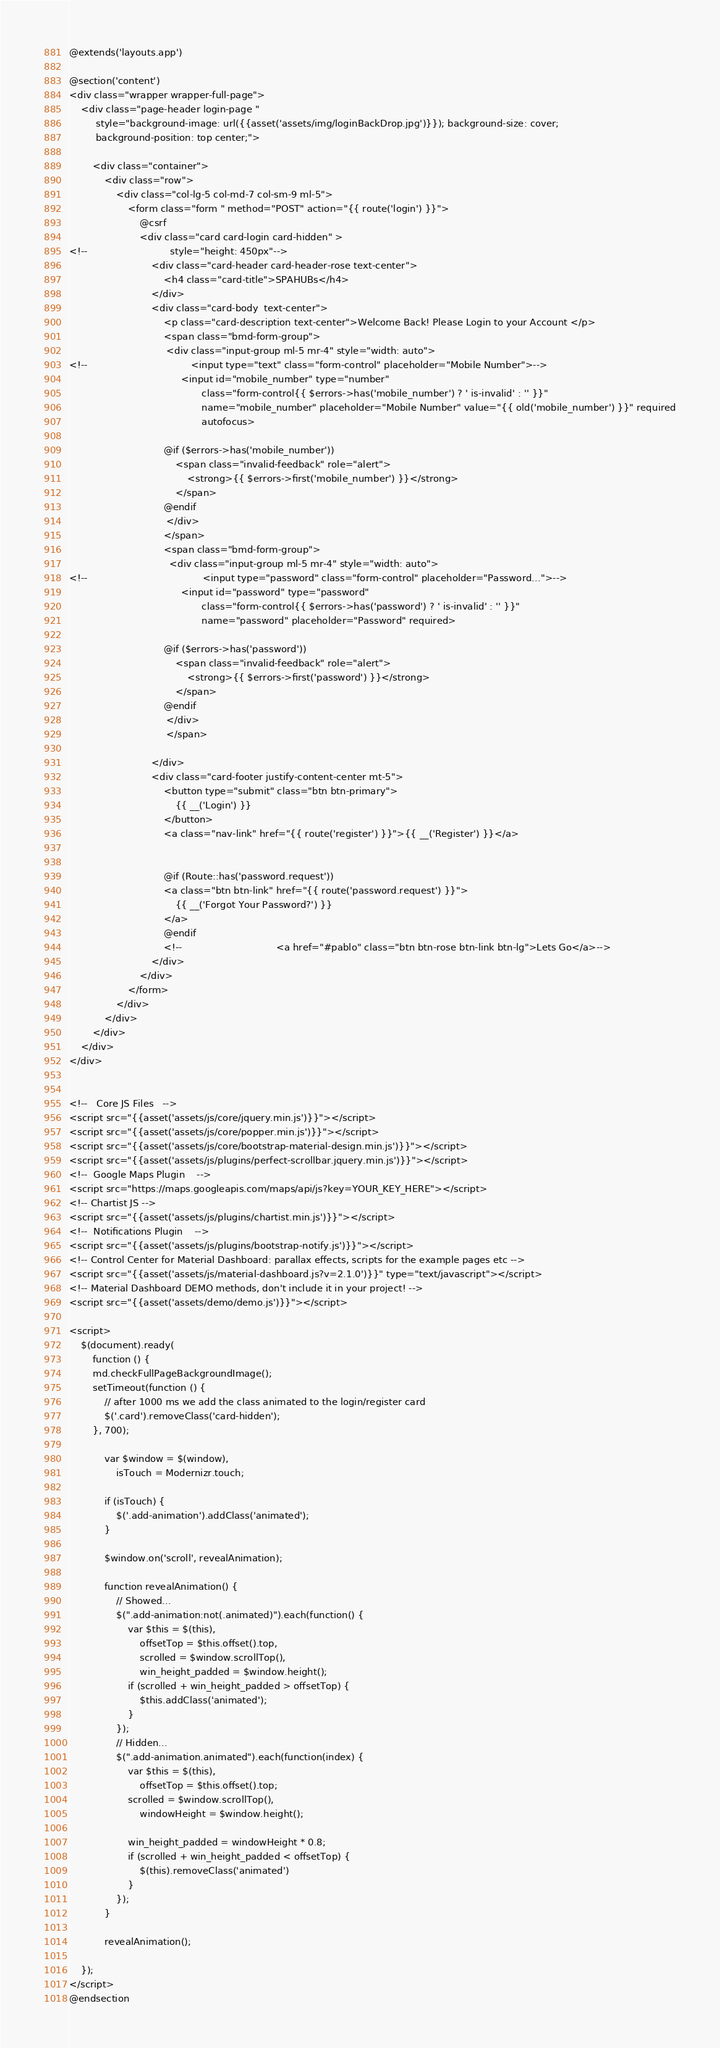<code> <loc_0><loc_0><loc_500><loc_500><_PHP_>@extends('layouts.app')

@section('content')
<div class="wrapper wrapper-full-page">
    <div class="page-header login-page "
         style="background-image: url({{asset('assets/img/loginBackDrop.jpg')}}); background-size: cover;
         background-position: top center;">

        <div class="container">
            <div class="row">
                <div class="col-lg-5 col-md-7 col-sm-9 ml-5">
                    <form class="form " method="POST" action="{{ route('login') }}">
                        @csrf
                        <div class="card card-login card-hidden" >
<!--                            style="height: 450px"-->
                            <div class="card-header card-header-rose text-center">
                                <h4 class="card-title">SPAHUBs</h4>
                            </div>
                            <div class="card-body  text-center">
                                <p class="card-description text-center">Welcome Back! Please Login to your Account </p>
                                <span class="bmd-form-group">
                                 <div class="input-group ml-5 mr-4" style="width: auto">
<!--                                   <input type="text" class="form-control" placeholder="Mobile Number">-->
                                      <input id="mobile_number" type="number"
                                             class="form-control{{ $errors->has('mobile_number') ? ' is-invalid' : '' }}"
                                             name="mobile_number" placeholder="Mobile Number" value="{{ old('mobile_number') }}" required
                                             autofocus>

                                @if ($errors->has('mobile_number'))
                                    <span class="invalid-feedback" role="alert">
                                        <strong>{{ $errors->first('mobile_number') }}</strong>
                                    </span>
                                @endif
                                 </div>
                                </span>
                                <span class="bmd-form-group">
                                  <div class="input-group ml-5 mr-4" style="width: auto">
<!--                                       <input type="password" class="form-control" placeholder="Password...">-->
                                      <input id="password" type="password"
                                             class="form-control{{ $errors->has('password') ? ' is-invalid' : '' }}"
                                             name="password" placeholder="Password" required>

                                @if ($errors->has('password'))
                                    <span class="invalid-feedback" role="alert">
                                        <strong>{{ $errors->first('password') }}</strong>
                                    </span>
                                @endif
                                 </div>
                                 </span>

                            </div>
                            <div class="card-footer justify-content-center mt-5">
                                <button type="submit" class="btn btn-primary">
                                    {{ __('Login') }}
                                </button>
                                <a class="nav-link" href="{{ route('register') }}">{{ __('Register') }}</a>


                                @if (Route::has('password.request'))
                                <a class="btn btn-link" href="{{ route('password.request') }}">
                                    {{ __('Forgot Your Password?') }}
                                </a>
                                @endif
                                <!--                                <a href="#pablo" class="btn btn-rose btn-link btn-lg">Lets Go</a>-->
                            </div>
                        </div>
                    </form>
                </div>
            </div>
        </div>
    </div>
</div>


<!--   Core JS Files   -->
<script src="{{asset('assets/js/core/jquery.min.js')}}"></script>
<script src="{{asset('assets/js/core/popper.min.js')}}"></script>
<script src="{{asset('assets/js/core/bootstrap-material-design.min.js')}}"></script>
<script src="{{asset('assets/js/plugins/perfect-scrollbar.jquery.min.js')}}"></script>
<!--  Google Maps Plugin    -->
<script src="https://maps.googleapis.com/maps/api/js?key=YOUR_KEY_HERE"></script>
<!-- Chartist JS -->
<script src="{{asset('assets/js/plugins/chartist.min.js')}}"></script>
<!--  Notifications Plugin    -->
<script src="{{asset('assets/js/plugins/bootstrap-notify.js')}}"></script>
<!-- Control Center for Material Dashboard: parallax effects, scripts for the example pages etc -->
<script src="{{asset('assets/js/material-dashboard.js?v=2.1.0')}}" type="text/javascript"></script>
<!-- Material Dashboard DEMO methods, don't include it in your project! -->
<script src="{{asset('assets/demo/demo.js')}}"></script>

<script>
    $(document).ready(
        function () {
        md.checkFullPageBackgroundImage();
        setTimeout(function () {
            // after 1000 ms we add the class animated to the login/register card
            $('.card').removeClass('card-hidden');
        }, 700);

            var $window = $(window),
                isTouch = Modernizr.touch;

            if (isTouch) {
                $('.add-animation').addClass('animated');
            }

            $window.on('scroll', revealAnimation);

            function revealAnimation() {
                // Showed...
                $(".add-animation:not(.animated)").each(function() {
                    var $this = $(this),
                        offsetTop = $this.offset().top,
                        scrolled = $window.scrollTop(),
                        win_height_padded = $window.height();
                    if (scrolled + win_height_padded > offsetTop) {
                        $this.addClass('animated');
                    }
                });
                // Hidden...
                $(".add-animation.animated").each(function(index) {
                    var $this = $(this),
                        offsetTop = $this.offset().top;
                    scrolled = $window.scrollTop(),
                        windowHeight = $window.height();

                    win_height_padded = windowHeight * 0.8;
                    if (scrolled + win_height_padded < offsetTop) {
                        $(this).removeClass('animated')
                    }
                });
            }

            revealAnimation();

    });
</script>
@endsection
</code> 